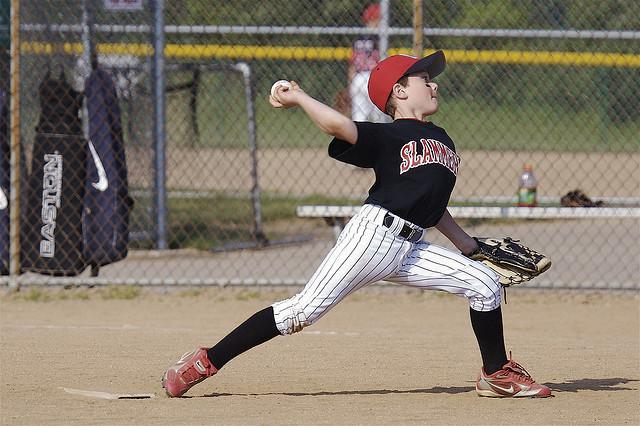Is this a color or black and white photo?
Write a very short answer. Color. Is the boy wearing any helmet?
Write a very short answer. No. What color is the man's shoes?
Answer briefly. Red. What is this sport?
Keep it brief. Baseball. What position does the boy play?
Give a very brief answer. Pitcher. Is his foot touching a base?
Write a very short answer. No. What is the young boy doing?
Be succinct. Pitching. 